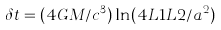Convert formula to latex. <formula><loc_0><loc_0><loc_500><loc_500>\delta t = ( 4 G M / c ^ { 3 } ) \ln ( 4 L 1 L 2 / a ^ { 2 } )</formula> 